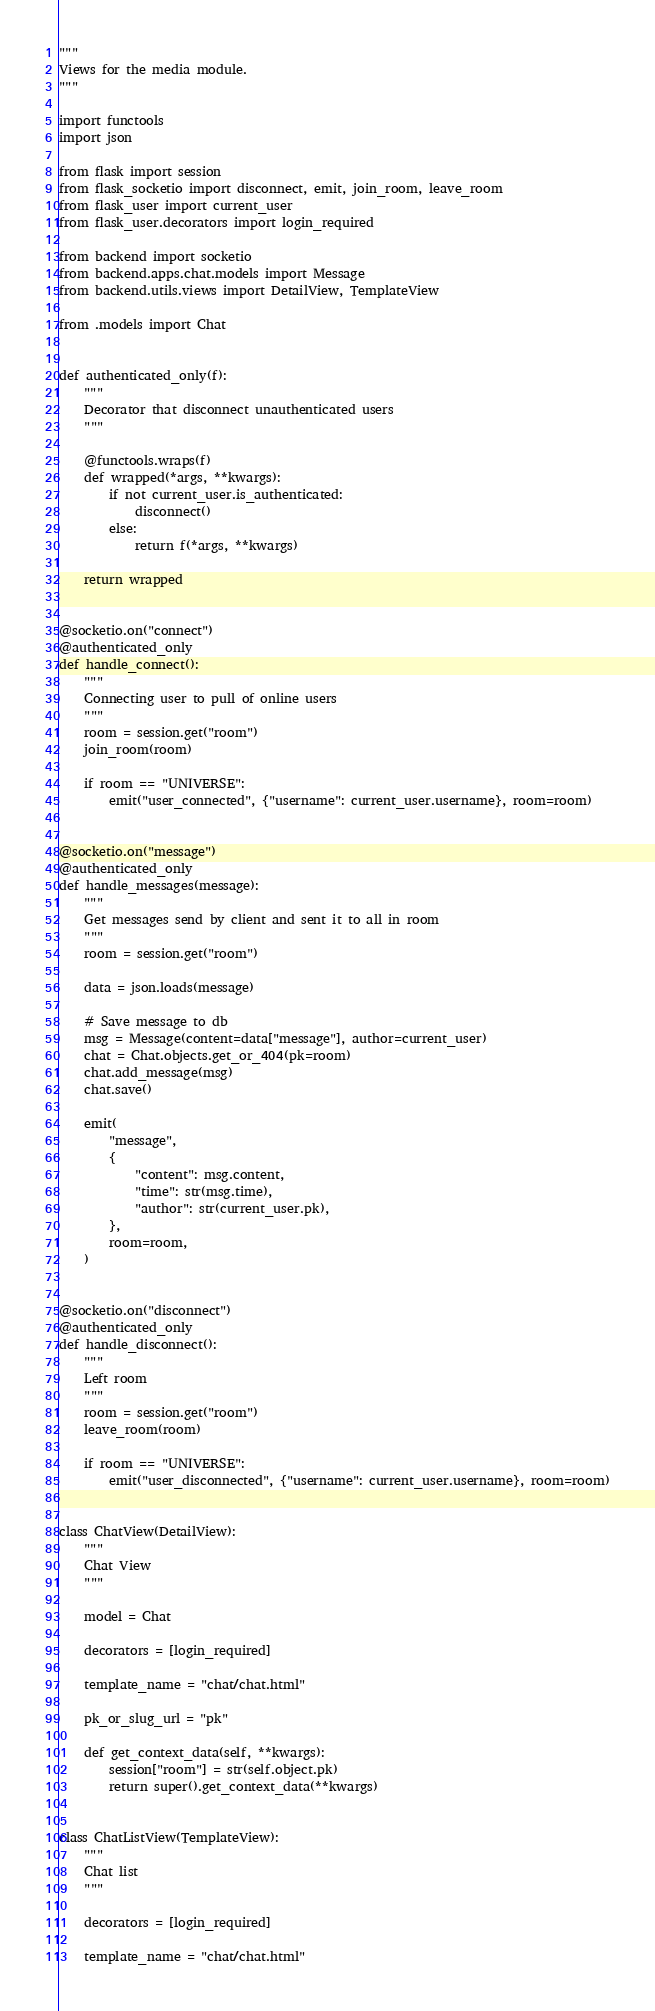<code> <loc_0><loc_0><loc_500><loc_500><_Python_>"""
Views for the media module.
"""

import functools
import json

from flask import session
from flask_socketio import disconnect, emit, join_room, leave_room
from flask_user import current_user
from flask_user.decorators import login_required

from backend import socketio
from backend.apps.chat.models import Message
from backend.utils.views import DetailView, TemplateView

from .models import Chat


def authenticated_only(f):
    """
    Decorator that disconnect unauthenticated users
    """

    @functools.wraps(f)
    def wrapped(*args, **kwargs):
        if not current_user.is_authenticated:
            disconnect()
        else:
            return f(*args, **kwargs)

    return wrapped


@socketio.on("connect")
@authenticated_only
def handle_connect():
    """
    Connecting user to pull of online users
    """
    room = session.get("room")
    join_room(room)

    if room == "UNIVERSE":
        emit("user_connected", {"username": current_user.username}, room=room)


@socketio.on("message")
@authenticated_only
def handle_messages(message):
    """
    Get messages send by client and sent it to all in room
    """
    room = session.get("room")

    data = json.loads(message)

    # Save message to db
    msg = Message(content=data["message"], author=current_user)
    chat = Chat.objects.get_or_404(pk=room)
    chat.add_message(msg)
    chat.save()

    emit(
        "message",
        {
            "content": msg.content,
            "time": str(msg.time),
            "author": str(current_user.pk),
        },
        room=room,
    )


@socketio.on("disconnect")
@authenticated_only
def handle_disconnect():
    """
    Left room
    """
    room = session.get("room")
    leave_room(room)

    if room == "UNIVERSE":
        emit("user_disconnected", {"username": current_user.username}, room=room)


class ChatView(DetailView):
    """
    Chat View
    """

    model = Chat

    decorators = [login_required]

    template_name = "chat/chat.html"

    pk_or_slug_url = "pk"

    def get_context_data(self, **kwargs):
        session["room"] = str(self.object.pk)
        return super().get_context_data(**kwargs)


class ChatListView(TemplateView):
    """
    Chat list
    """

    decorators = [login_required]

    template_name = "chat/chat.html"
</code> 